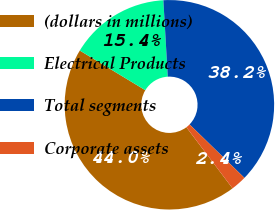Convert chart to OTSL. <chart><loc_0><loc_0><loc_500><loc_500><pie_chart><fcel>(dollars in millions)<fcel>Electrical Products<fcel>Total segments<fcel>Corporate assets<nl><fcel>43.96%<fcel>15.42%<fcel>38.21%<fcel>2.41%<nl></chart> 